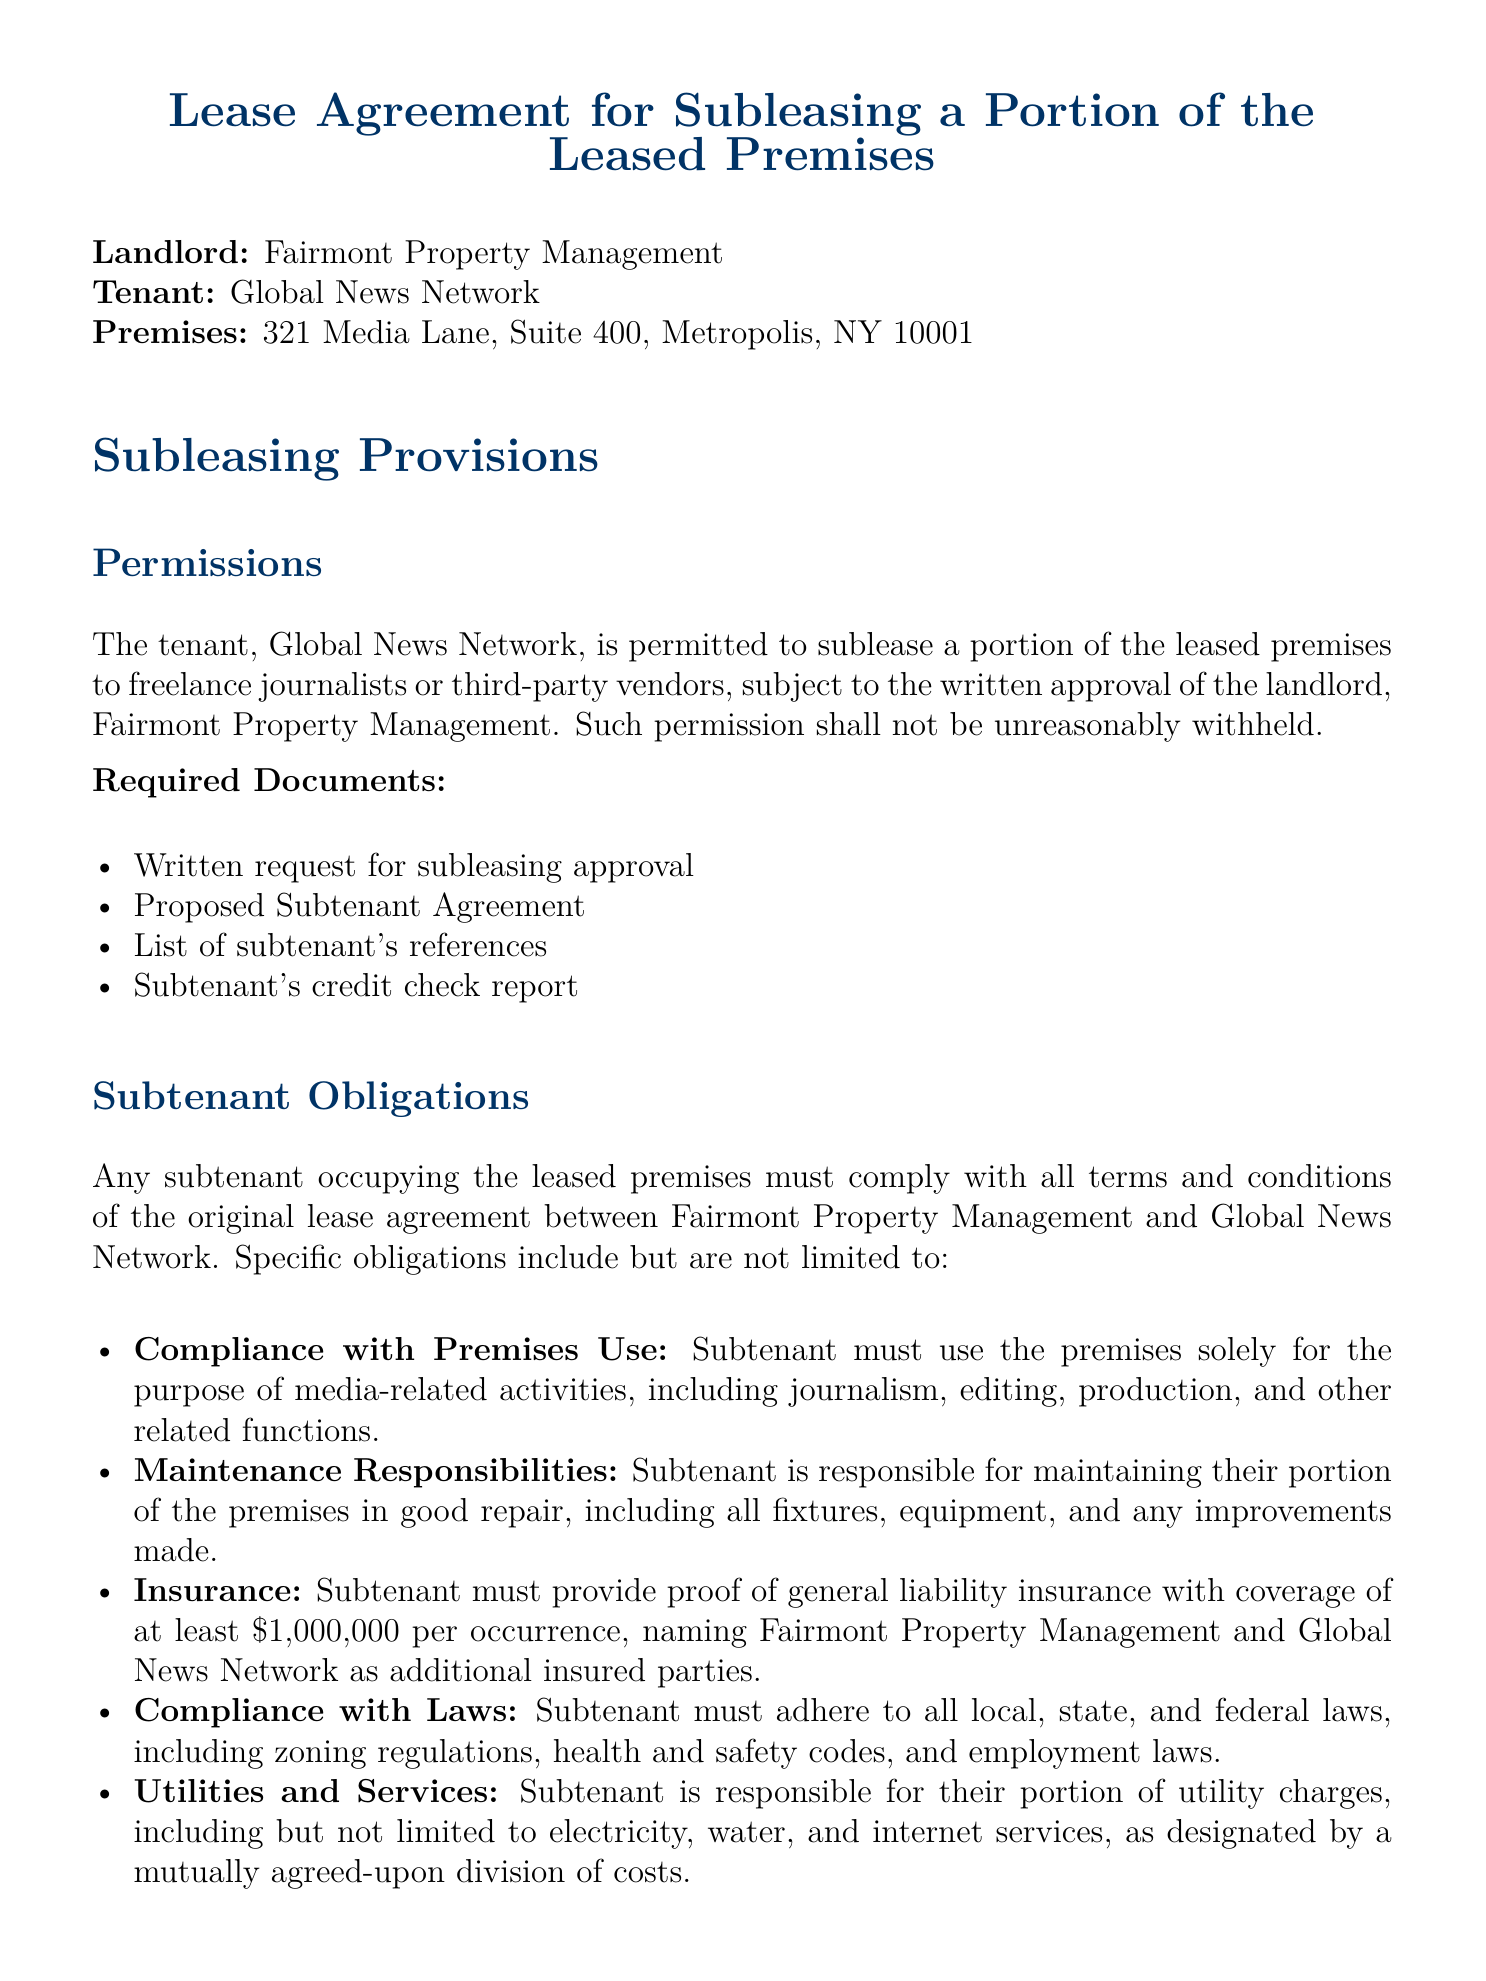what is the name of the landlord? The landlord specified in the document is Fairmont Property Management.
Answer: Fairmont Property Management who is the tenant in the lease agreement? The tenant identified in the lease agreement is Global News Network.
Answer: Global News Network where are the leased premises located? The address of the leased premises is provided in the document as 321 Media Lane, Suite 400, Metropolis, NY 10001.
Answer: 321 Media Lane, Suite 400, Metropolis, NY 10001 what is the minimum insurance coverage required for subtenants? The document states that subtenants must provide proof of general liability insurance with a minimum coverage of one million dollars per occurrence.
Answer: $1,000,000 what must subtenants comply with regarding the use of premises? Subtenants must use the premises solely for media-related activities, including journalism, editing, production, and other related functions.
Answer: media-related activities what are subtenants responsible for maintaining? Subtenants are responsible for maintaining their portion of the premises, which includes all fixtures, equipment, and any improvements made.
Answer: their portion of the premises how many required documents are listed for subleasing approval? The document lists four required documents for subleasing approval.
Answer: four what can the landlord do if a proposed subtenant is deemed incompatible? The landlord has the right to reject any proposed subtenant if their intended use or business practices are incompatible with the property or community standards.
Answer: reject what must subtenants provide as part of their obligations? Subtenants must provide proof of general liability insurance and compliance with all terms and conditions of the original lease agreement.
Answer: proof of general liability insurance 